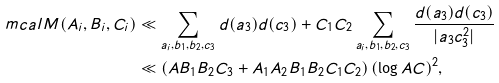<formula> <loc_0><loc_0><loc_500><loc_500>\ m c a l { M } ( A _ { i } , B _ { i } , C _ { i } ) & \ll \sum _ { a _ { i } , b _ { 1 } , b _ { 2 } , c _ { 3 } } d ( a _ { 3 } ) d ( c _ { 3 } ) + C _ { 1 } C _ { 2 } \sum _ { a _ { i } , b _ { 1 } , b _ { 2 } , c _ { 3 } } \frac { d ( a _ { 3 } ) d ( c _ { 3 } ) } { | a _ { 3 } c _ { 3 } ^ { 2 } | } \\ & \ll \left ( A B _ { 1 } B _ { 2 } C _ { 3 } + A _ { 1 } A _ { 2 } B _ { 1 } B _ { 2 } C _ { 1 } C _ { 2 } \right ) ( \log A C ) ^ { 2 } ,</formula> 